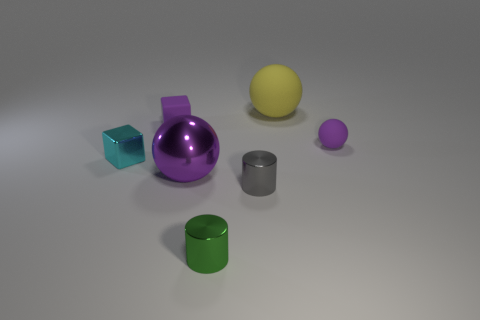There is a small cube that is the same material as the tiny gray thing; what is its color?
Offer a terse response. Cyan. Are there the same number of yellow balls to the left of the big yellow thing and yellow cubes?
Keep it short and to the point. Yes. Do the purple sphere that is to the left of the purple rubber sphere and the green shiny cylinder have the same size?
Offer a very short reply. No. There is a matte thing that is the same size as the metal sphere; what is its color?
Make the answer very short. Yellow. Are there any large purple metallic things in front of the rubber thing in front of the rubber cube that is behind the small green metallic thing?
Provide a succinct answer. Yes. What is the large ball on the right side of the gray cylinder made of?
Ensure brevity in your answer.  Rubber. There is a large yellow rubber thing; is its shape the same as the purple matte object that is in front of the tiny purple rubber block?
Make the answer very short. Yes. Are there the same number of small cyan objects to the right of the big yellow sphere and tiny green cylinders behind the tiny purple rubber sphere?
Offer a terse response. Yes. What number of other objects are there of the same material as the green thing?
Your answer should be very brief. 3. How many metallic objects are purple objects or balls?
Provide a succinct answer. 1. 